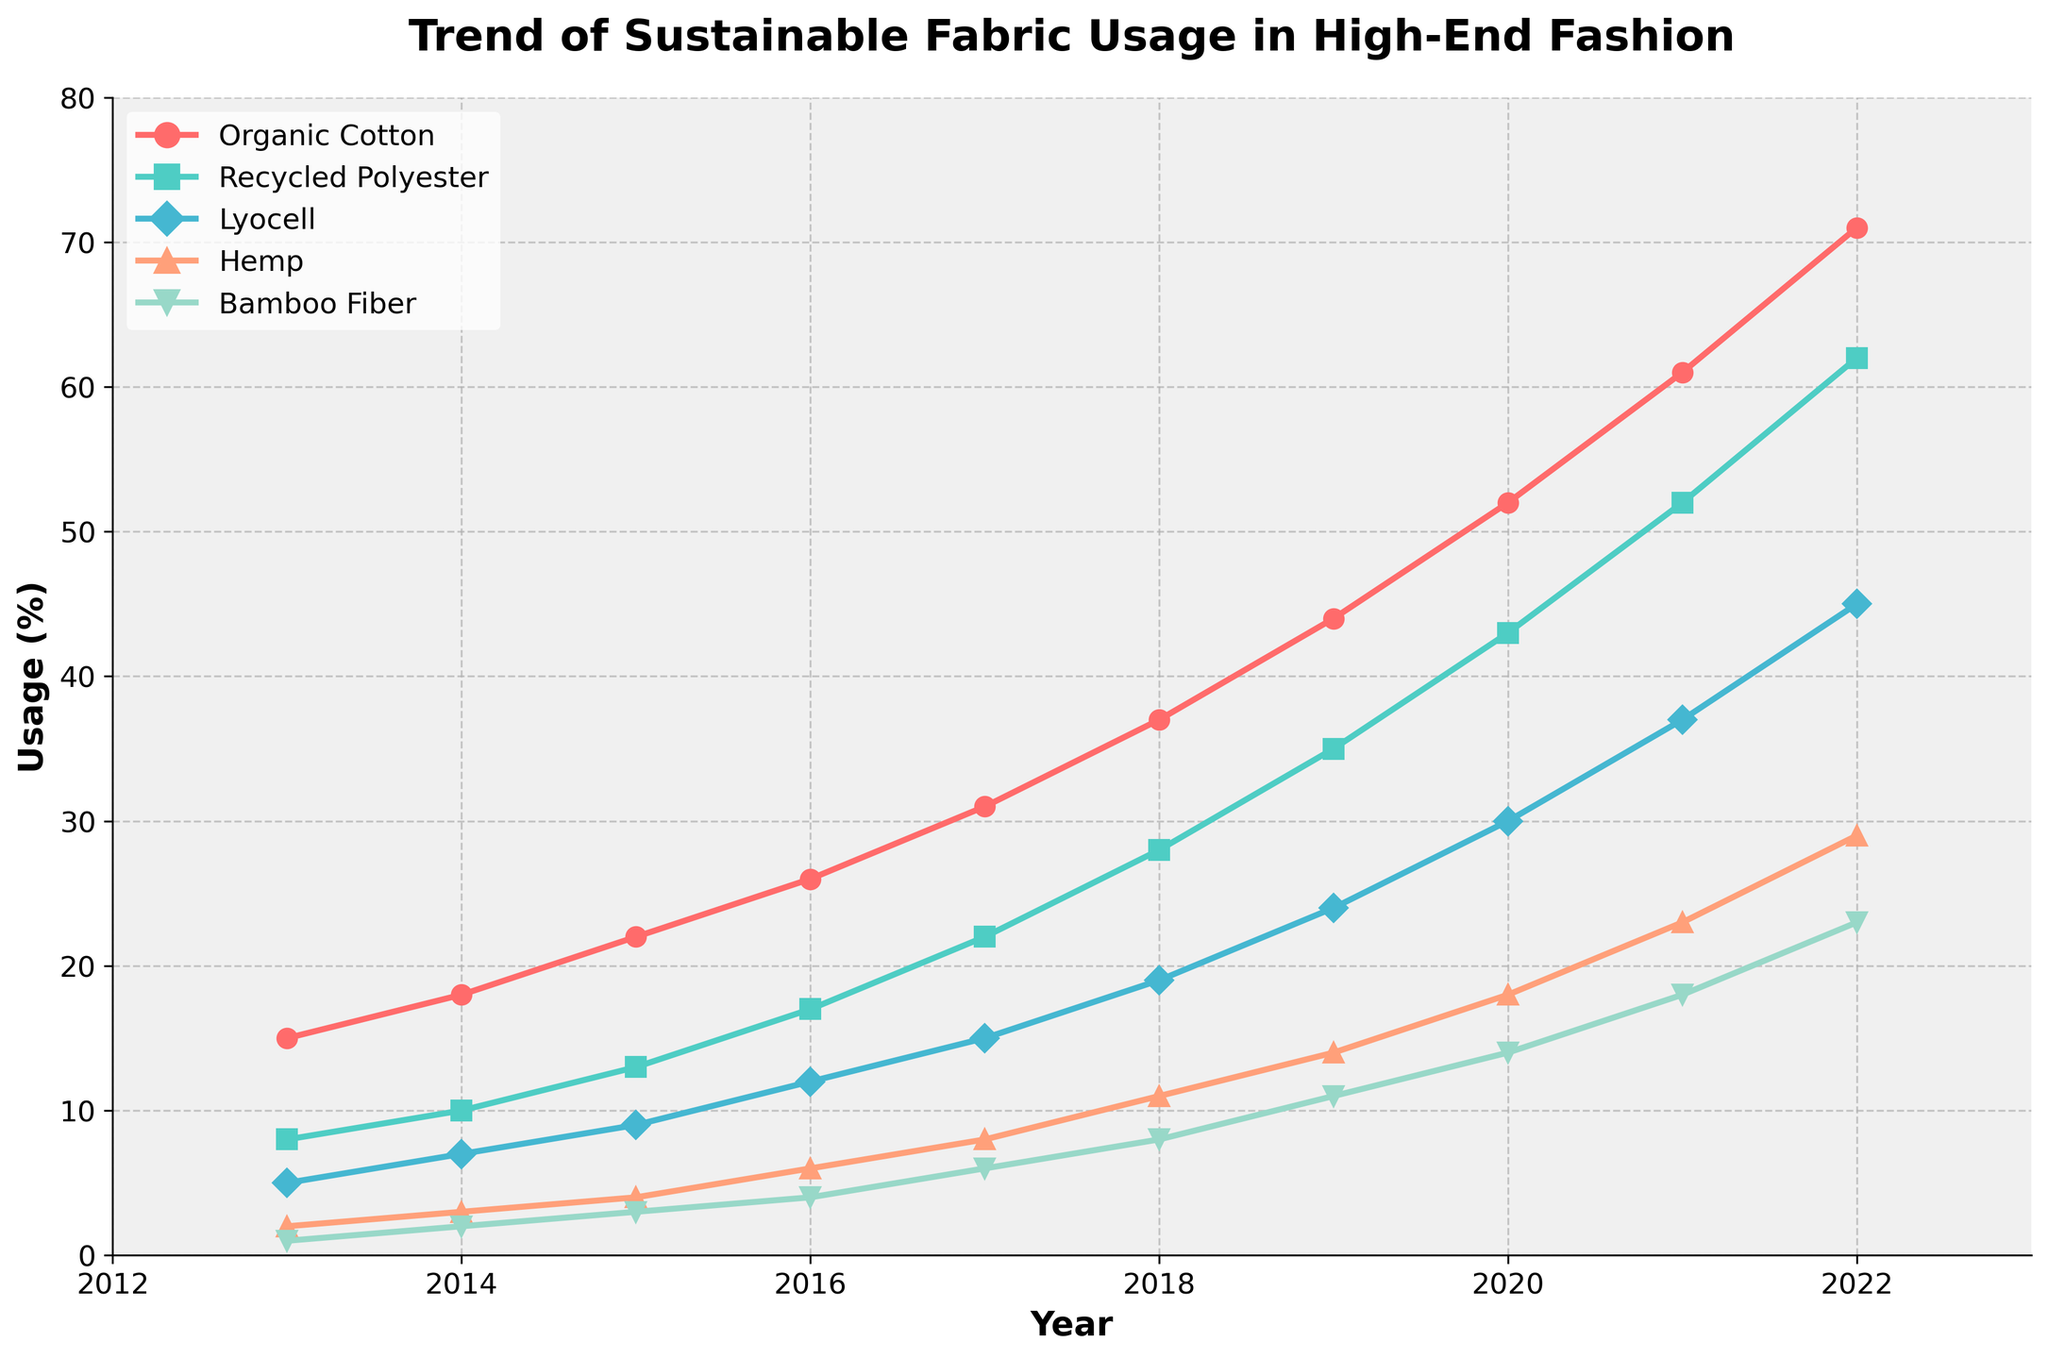What is the usage percentage of Organic Cotton in 2022? Finding the Organic Cotton line and moving to the year 2022 on the x-axis, the usage percentage is represented by the point where the line meets.
Answer: 71% Which material had the highest increase in usage percentage from 2018 to 2022? To determine the highest increase, calculate the difference in usage for each material between 2018 and 2022 and identify the material with the largest difference. Organic Cotton increased by 34%, Recycled Polyester by 34%, Lyocell by 26%, Hemp by 18%, and Bamboo Fiber by 15%.
Answer: Organic Cotton Which material had the lowest initial usage in 2013? By observing the starting points of each line in the graph, Bamboo Fiber starts at 1%, which is the lowest among all materials in 2013.
Answer: Bamboo Fiber For 2020, was the usage of Recycled Polyester higher or lower than Lyocell? Comparing the points for both materials at the year 2020 on the graph, Recycled Polyester has a higher position than Lyocell.
Answer: Higher What is the average usage percentage of Hemp from 2013 to 2022? Sum the usage percentages of Hemp for each year from 2013 to 2022 and divide by the number of years: (2+3+4+6+8+11+14+18+23+29)/10 = 11.8
Answer: 11.8% By how much did the usage percentage of Organic Cotton surpass Bamboo Fiber in 2022? Subtract Bamboo Fiber's value from Organic Cotton's value in 2022: 71% - 23% = 48%
Answer: 48% Which material shows a consistent increase in usage percentage every year? Each material's line needs to be checked for any dips or flat segments. All lines show consistent upward trends without decreases.
Answer: All materials Which year did Recycled Polyester usage reach at least 50% for the first time? Following the Recycled Polyester line, it reaches 52% in the year 2021.
Answer: 2021 Is the slope of the line representing Lyocell steeper from 2018 to 2019 or from 2021 to 2022? Calculate the difference: From 2018 to 2019 it's (24% - 19%) = 5%, and from 2021 to 2022 it's (45% - 37%) = 8%. The steeper slope is between 2021 and 2022.
Answer: 2021 to 2022 What is the overall trend in the usage of sustainable fabrics in high-end fashion over the past decade? By observing all the lines on the graph, they all show an upward trend over the years, indicating a collective increase in the usage of sustainable fabrics.
Answer: Increasing 